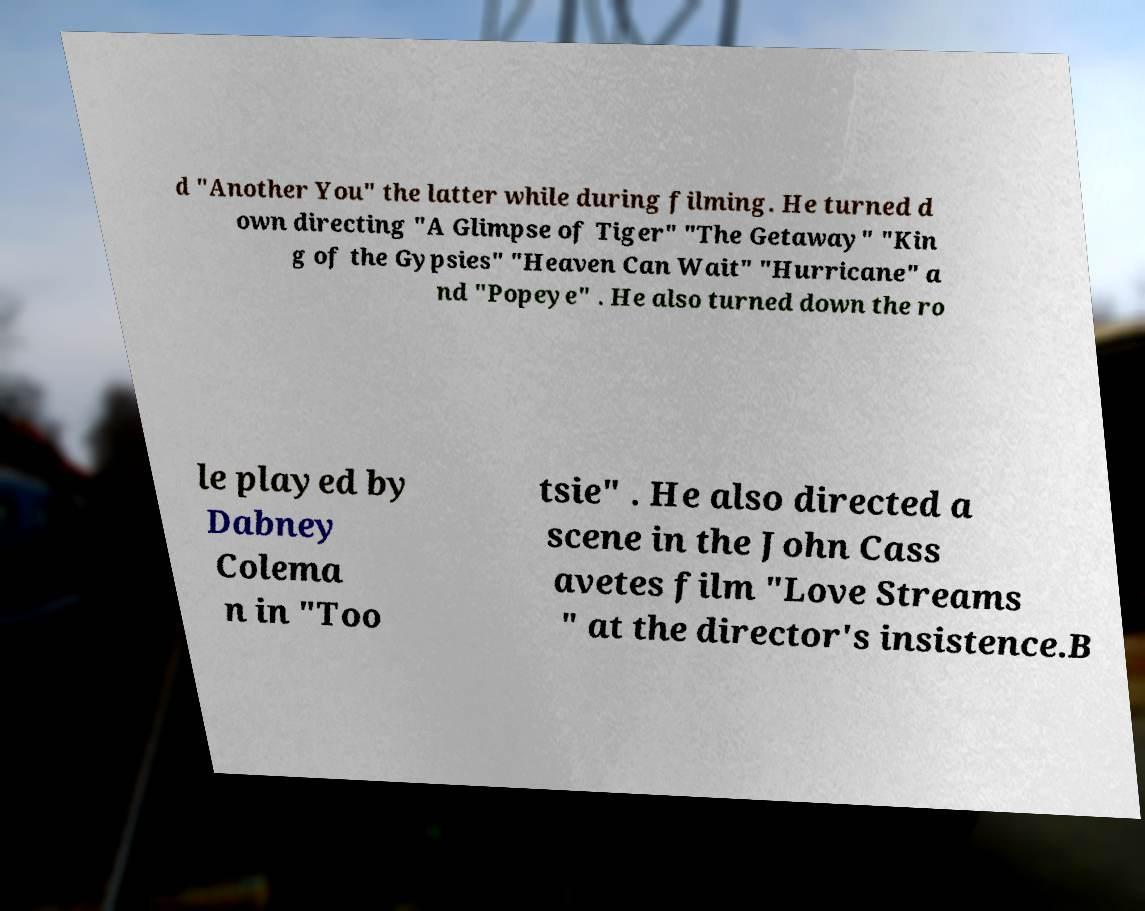There's text embedded in this image that I need extracted. Can you transcribe it verbatim? d "Another You" the latter while during filming. He turned d own directing "A Glimpse of Tiger" "The Getaway" "Kin g of the Gypsies" "Heaven Can Wait" "Hurricane" a nd "Popeye" . He also turned down the ro le played by Dabney Colema n in "Too tsie" . He also directed a scene in the John Cass avetes film "Love Streams " at the director's insistence.B 